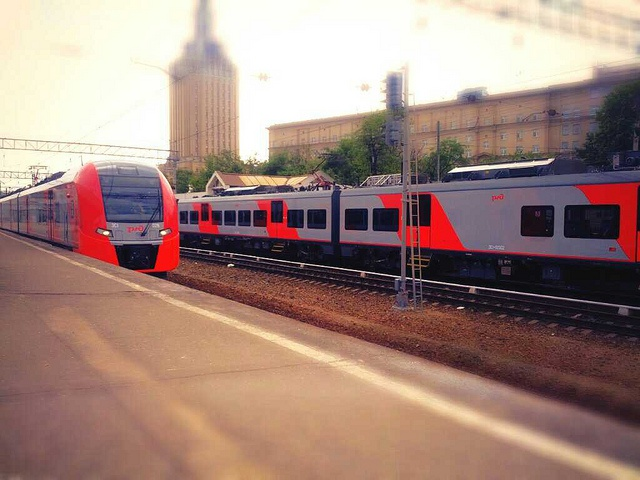Describe the objects in this image and their specific colors. I can see train in beige, black, gray, and red tones and train in beige, gray, red, black, and brown tones in this image. 